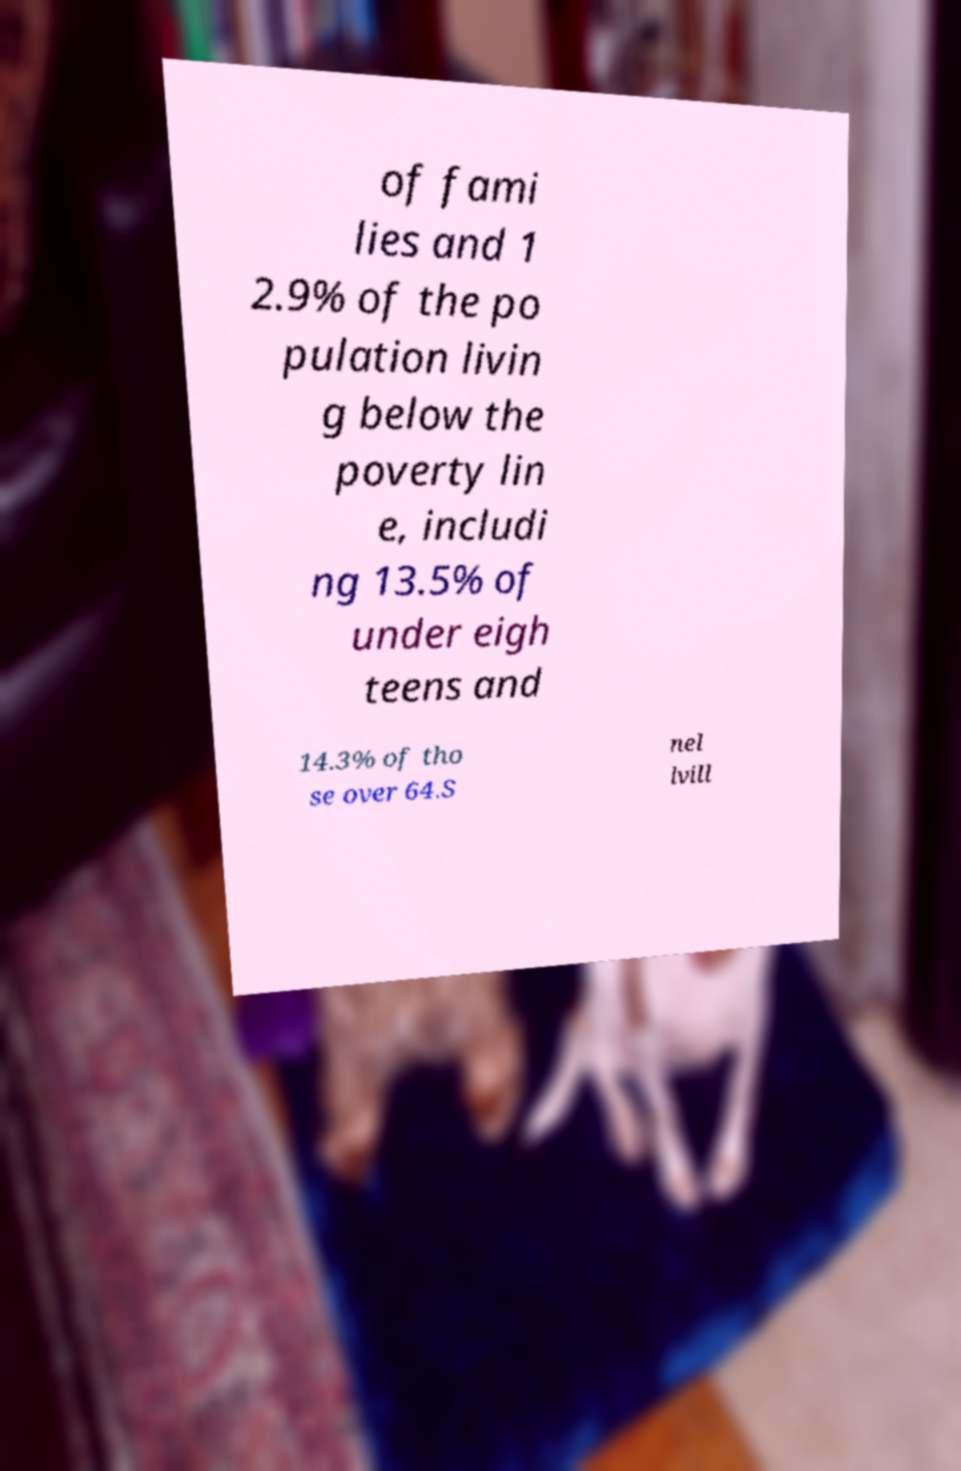Please read and relay the text visible in this image. What does it say? of fami lies and 1 2.9% of the po pulation livin g below the poverty lin e, includi ng 13.5% of under eigh teens and 14.3% of tho se over 64.S nel lvill 